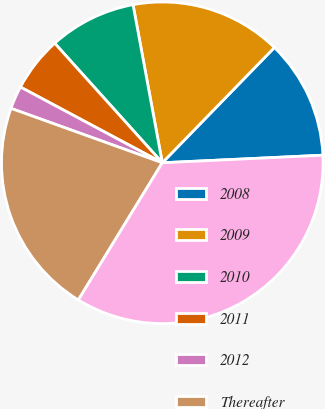<chart> <loc_0><loc_0><loc_500><loc_500><pie_chart><fcel>2008<fcel>2009<fcel>2010<fcel>2011<fcel>2012<fcel>Thereafter<fcel>Total minimum lease payments<nl><fcel>11.97%<fcel>15.19%<fcel>8.75%<fcel>5.53%<fcel>2.31%<fcel>21.75%<fcel>34.49%<nl></chart> 